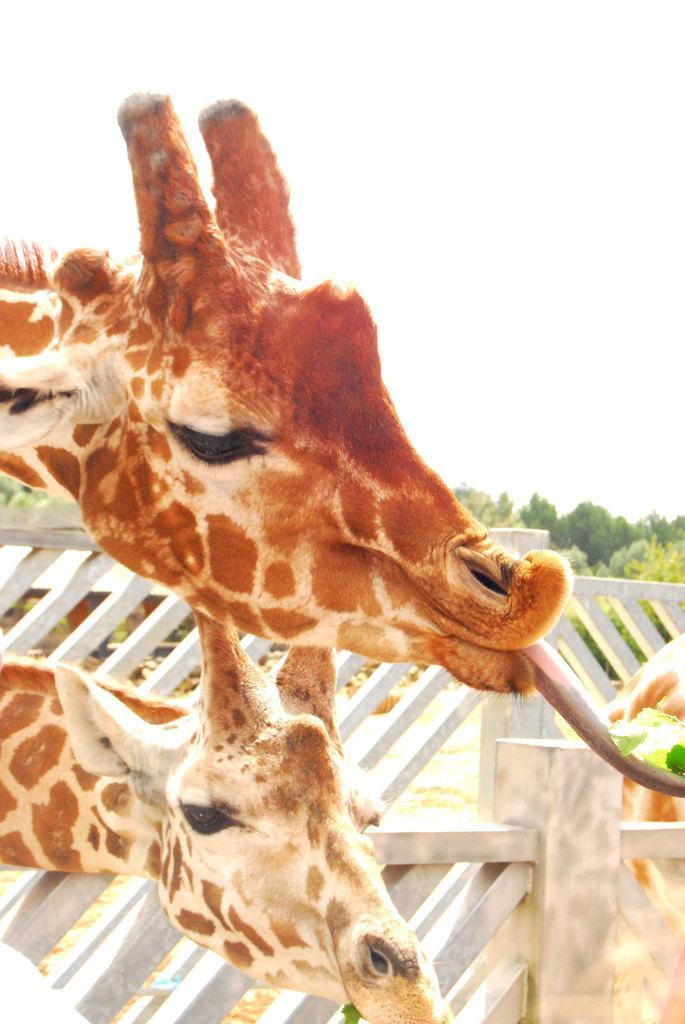In one or two sentences, can you explain what this image depicts? In this image I can see two giraffes head visible in front of the fence and I can see the sky and trees visible. 